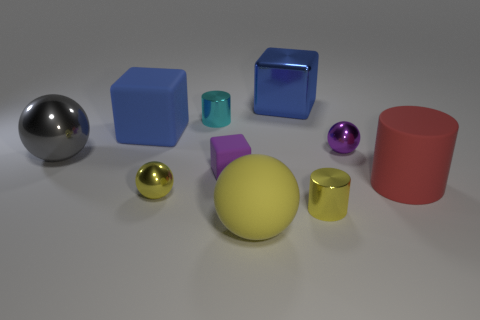Subtract all cylinders. How many objects are left? 7 Subtract all tiny yellow cylinders. Subtract all yellow matte things. How many objects are left? 8 Add 2 rubber things. How many rubber things are left? 6 Add 10 tiny red metallic balls. How many tiny red metallic balls exist? 10 Subtract 0 brown blocks. How many objects are left? 10 